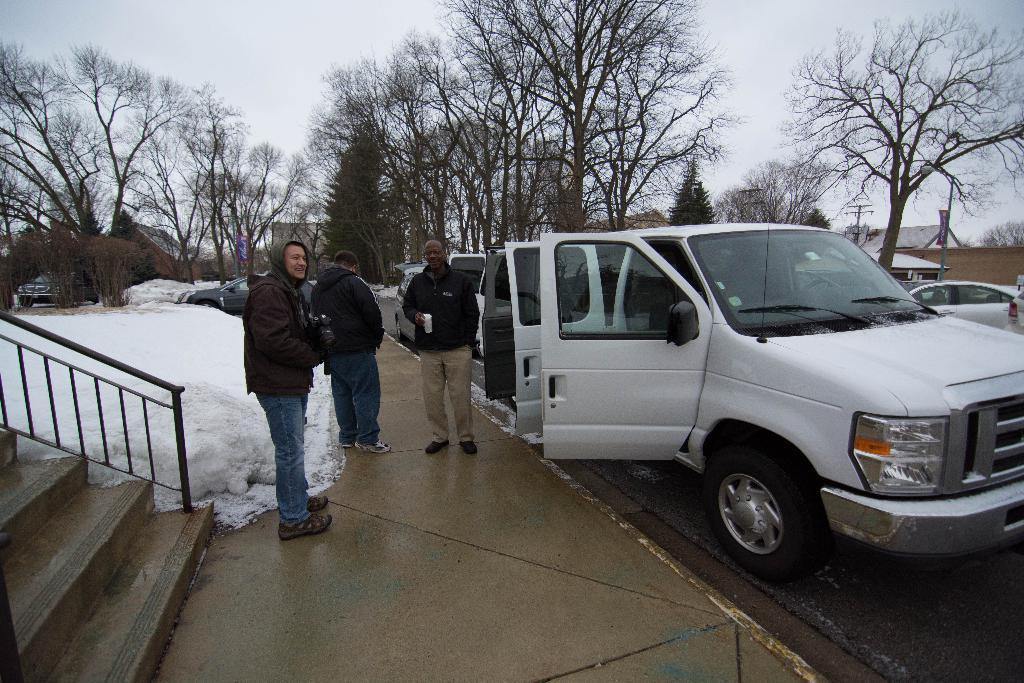In one or two sentences, can you explain what this image depicts? In this picture, we can see three people are standing on the path and on the left side of the people there are steps, fence and snow. On the right side of the people there are vehicles on the road, trees, pole and a sky. 